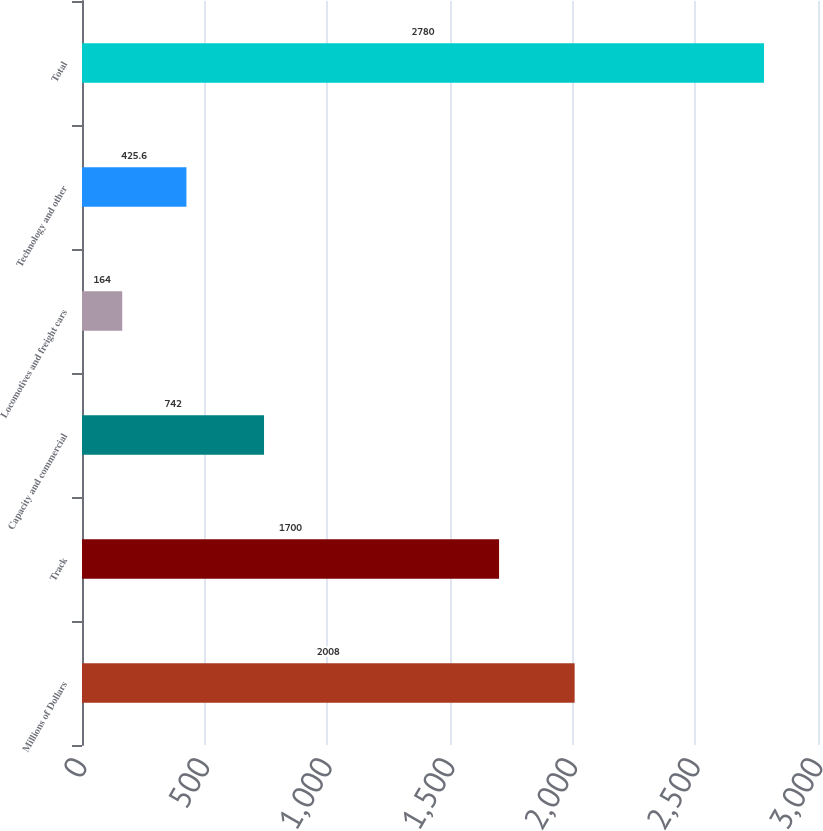Convert chart. <chart><loc_0><loc_0><loc_500><loc_500><bar_chart><fcel>Millions of Dollars<fcel>Track<fcel>Capacity and commercial<fcel>Locomotives and freight cars<fcel>Technology and other<fcel>Total<nl><fcel>2008<fcel>1700<fcel>742<fcel>164<fcel>425.6<fcel>2780<nl></chart> 